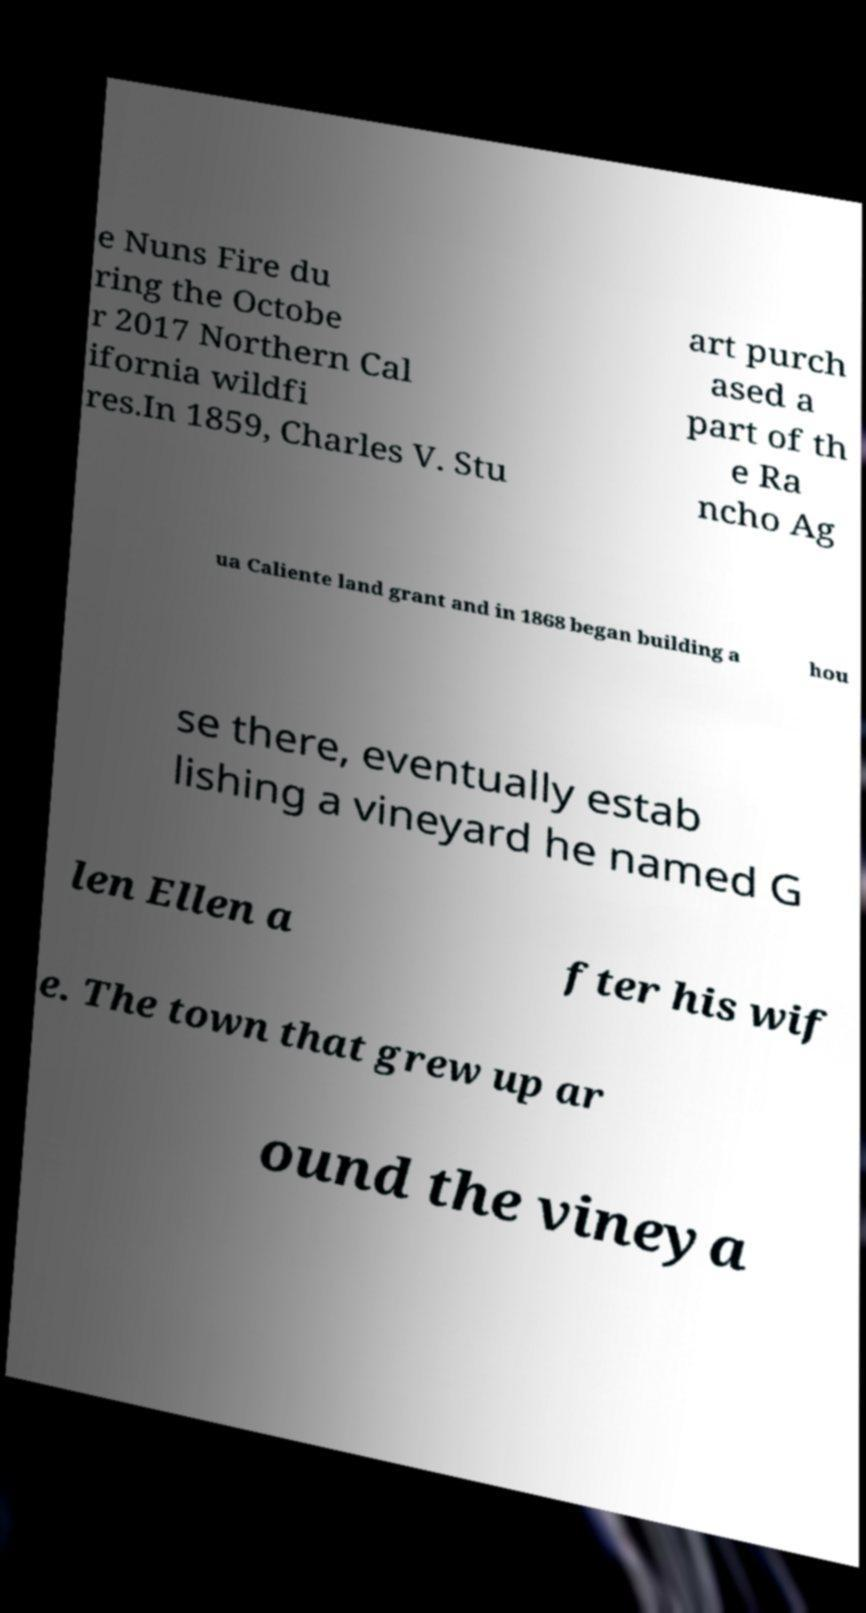Please read and relay the text visible in this image. What does it say? e Nuns Fire du ring the Octobe r 2017 Northern Cal ifornia wildfi res.In 1859, Charles V. Stu art purch ased a part of th e Ra ncho Ag ua Caliente land grant and in 1868 began building a hou se there, eventually estab lishing a vineyard he named G len Ellen a fter his wif e. The town that grew up ar ound the vineya 